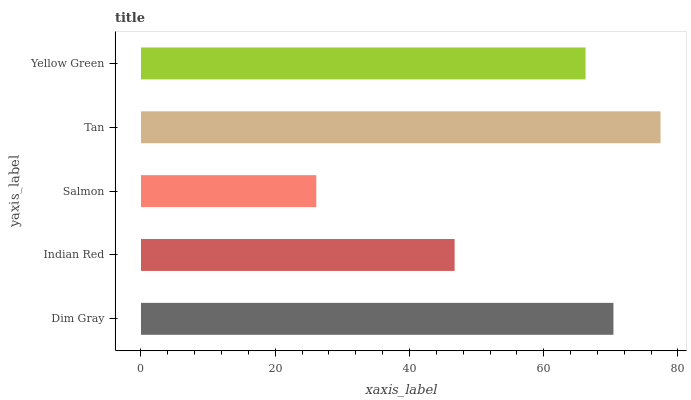Is Salmon the minimum?
Answer yes or no. Yes. Is Tan the maximum?
Answer yes or no. Yes. Is Indian Red the minimum?
Answer yes or no. No. Is Indian Red the maximum?
Answer yes or no. No. Is Dim Gray greater than Indian Red?
Answer yes or no. Yes. Is Indian Red less than Dim Gray?
Answer yes or no. Yes. Is Indian Red greater than Dim Gray?
Answer yes or no. No. Is Dim Gray less than Indian Red?
Answer yes or no. No. Is Yellow Green the high median?
Answer yes or no. Yes. Is Yellow Green the low median?
Answer yes or no. Yes. Is Dim Gray the high median?
Answer yes or no. No. Is Dim Gray the low median?
Answer yes or no. No. 